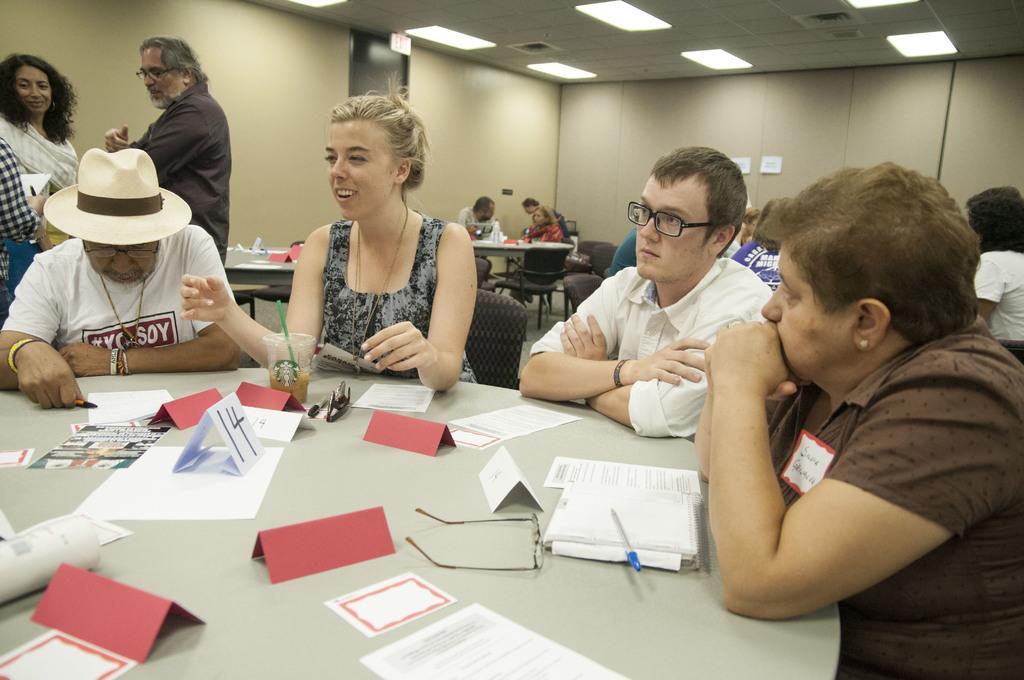How would you summarize this image in a sentence or two? In this picture we can see some people are sitting on chairs in front of tables, there are some papers, cards, a glass, goggles, spectacles, a pen and a marker present on the table, on the left side there are two persons standing, we can see the ceiling and lights at the top of the picture. 